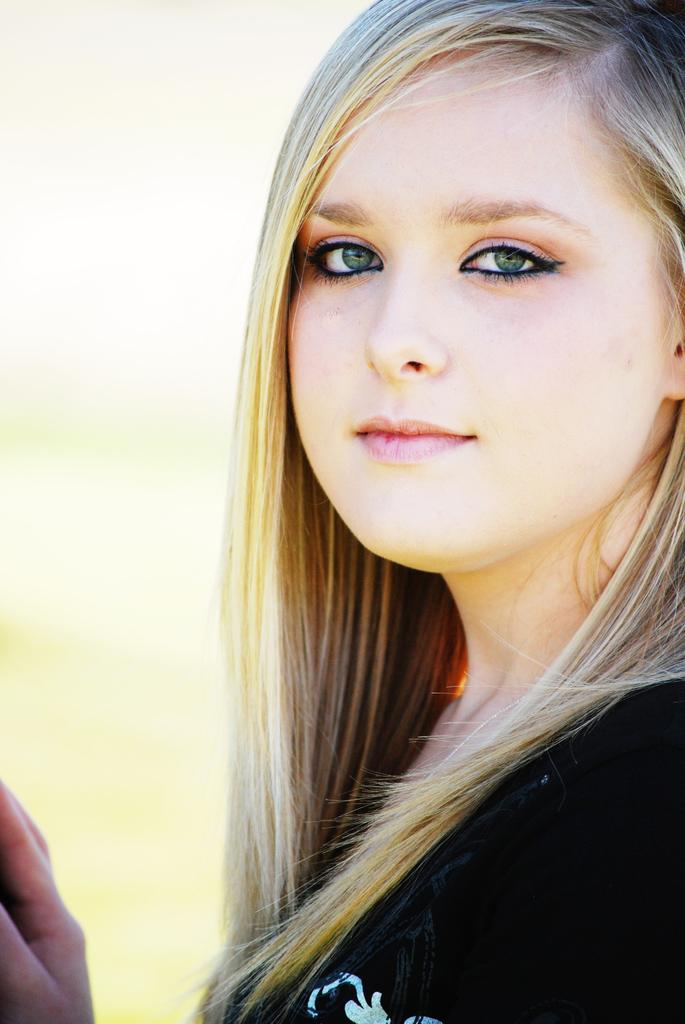Who is the main subject in the image? There is a woman in the image. What is the woman wearing? The woman is wearing a black t-shirt. What can be observed about the woman's eyes? The woman has green eyes. Can you describe the background of the image? The background of the image is blurred. How much salt is present on the woman's thumb in the image? There is no salt or thumb visible in the image; the woman's eyes and clothing are the focus. 